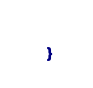Convert code to text. <code><loc_0><loc_0><loc_500><loc_500><_Ceylon_>    
}</code> 